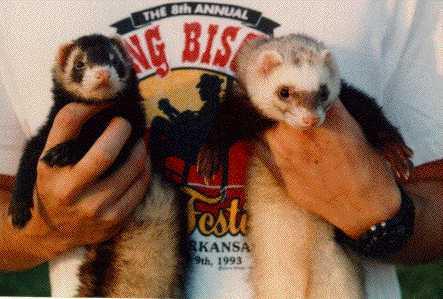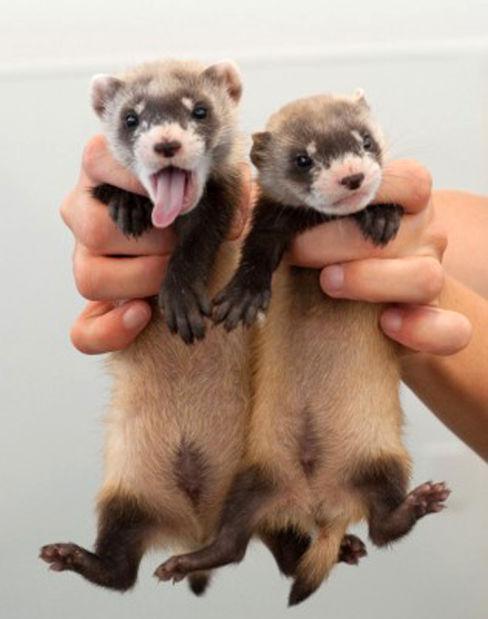The first image is the image on the left, the second image is the image on the right. For the images displayed, is the sentence "Someone is holding all the animals in the images." factually correct? Answer yes or no. Yes. 